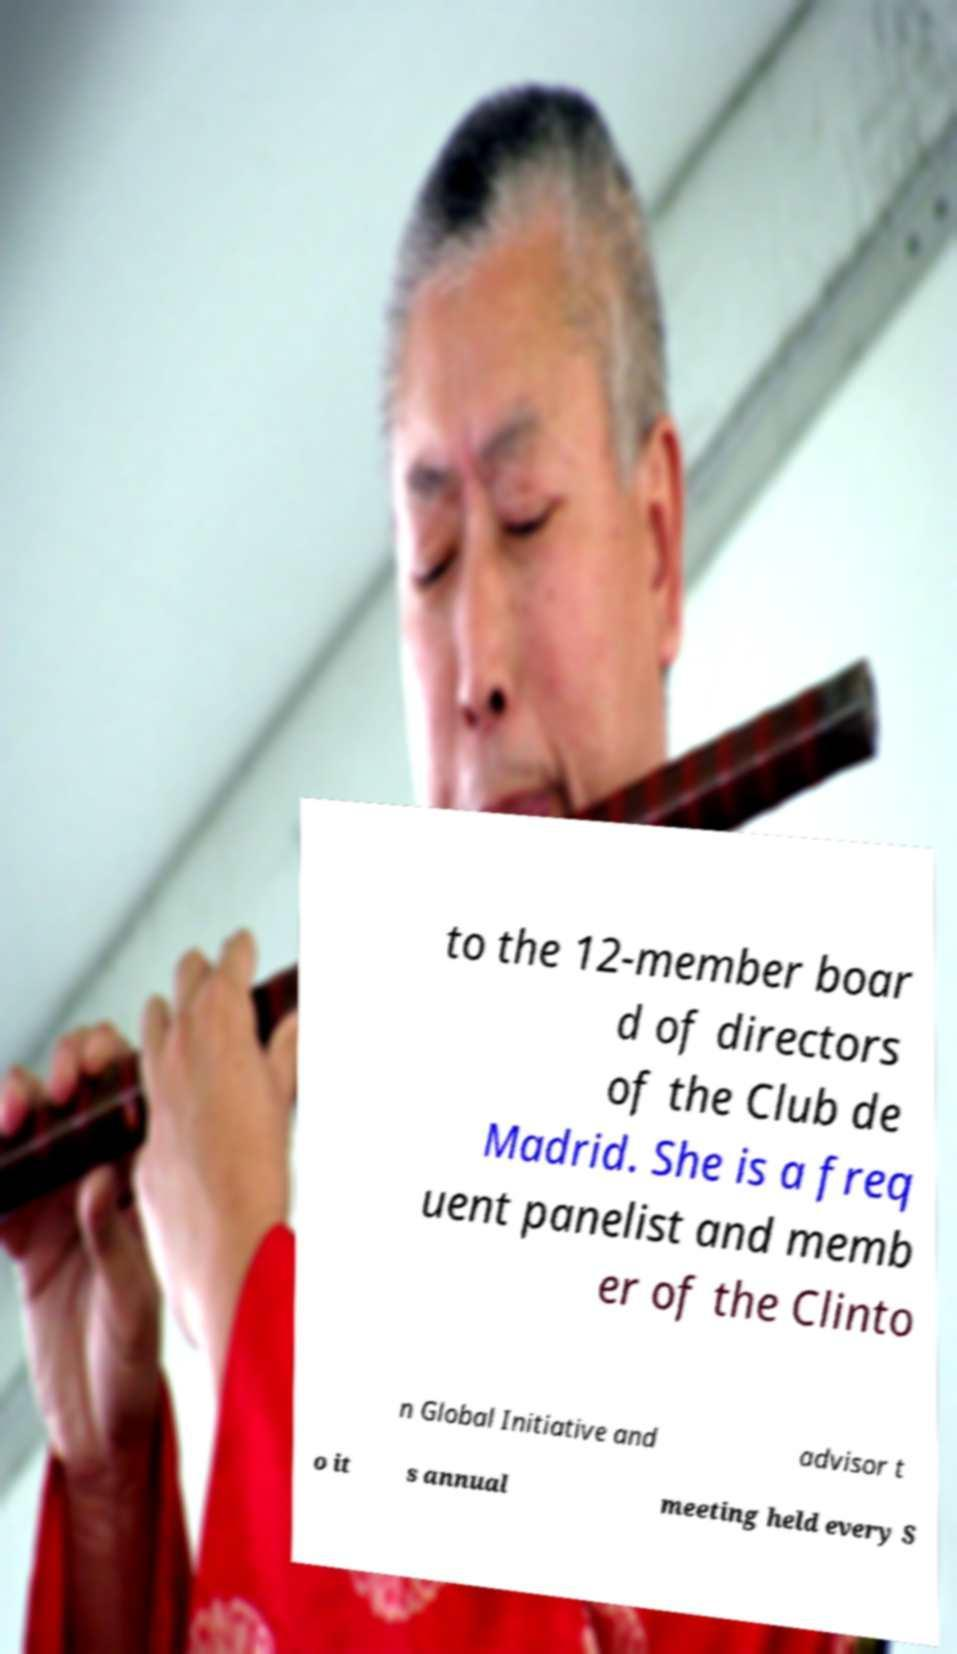Can you accurately transcribe the text from the provided image for me? to the 12-member boar d of directors of the Club de Madrid. She is a freq uent panelist and memb er of the Clinto n Global Initiative and advisor t o it s annual meeting held every S 